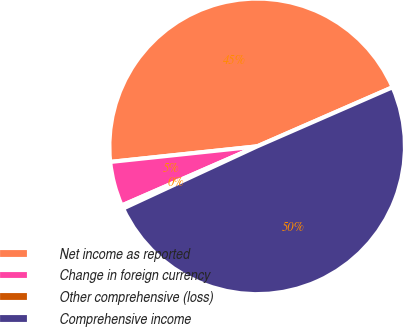Convert chart. <chart><loc_0><loc_0><loc_500><loc_500><pie_chart><fcel>Net income as reported<fcel>Change in foreign currency<fcel>Other comprehensive (loss)<fcel>Comprehensive income<nl><fcel>45.13%<fcel>4.87%<fcel>0.36%<fcel>49.64%<nl></chart> 